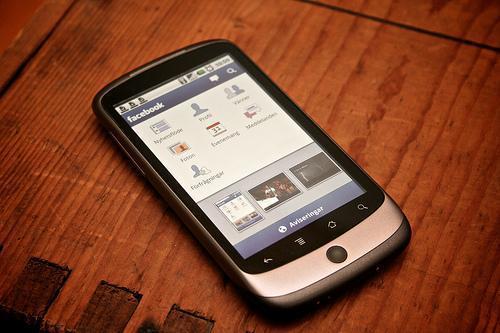How many items are displayed on the top display bar?
Give a very brief answer. 8. How many head silhouettes are on the screen?
Give a very brief answer. 4. 